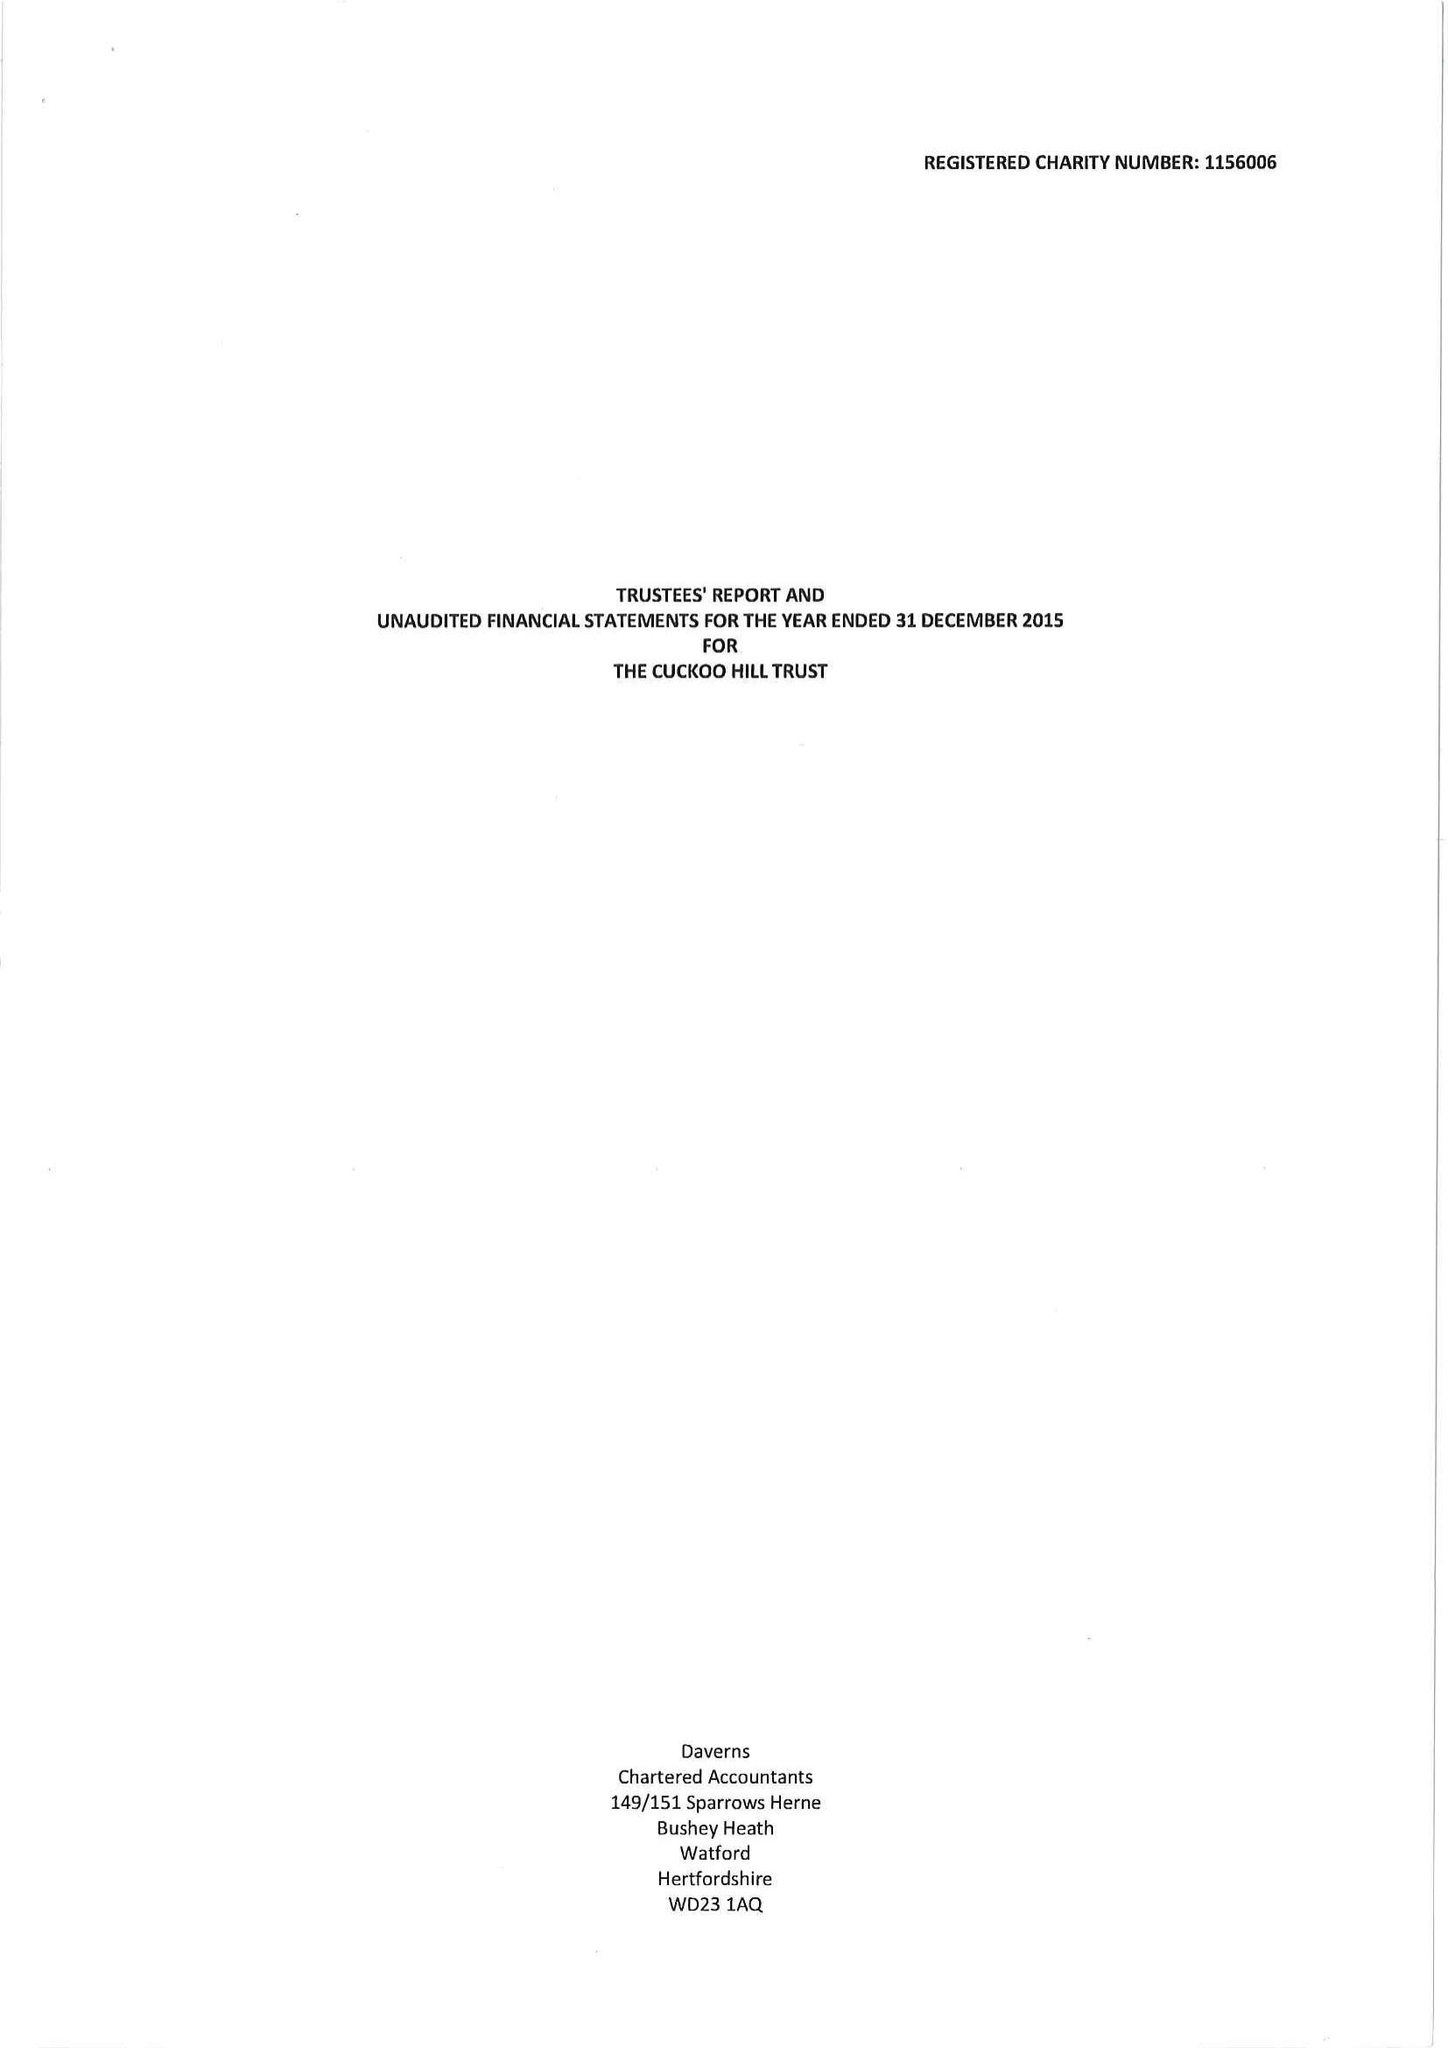What is the value for the income_annually_in_british_pounds?
Answer the question using a single word or phrase. 206500.00 